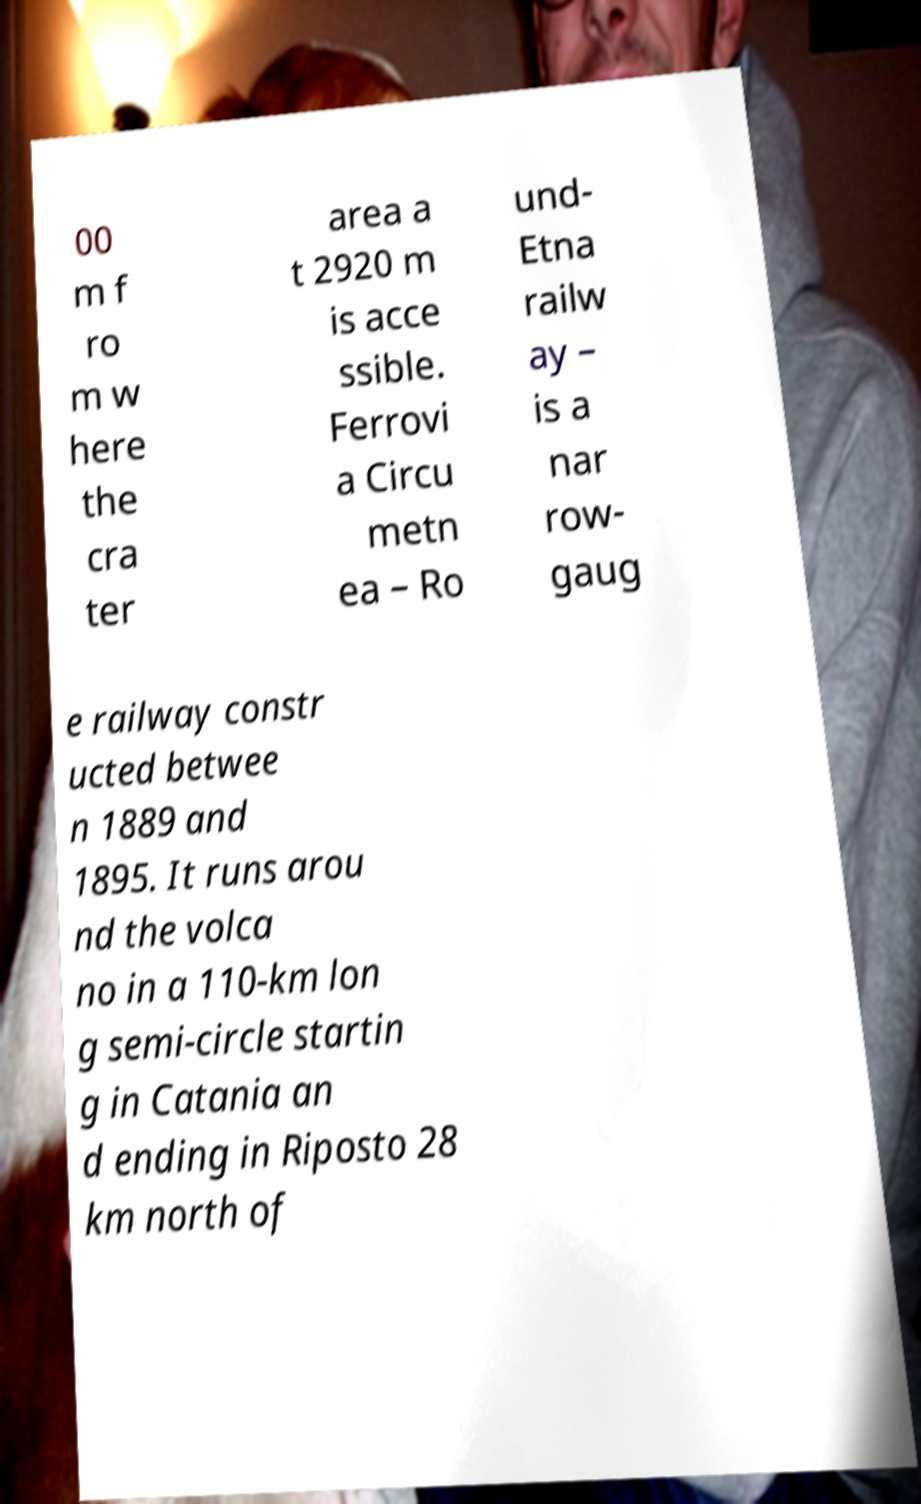Could you assist in decoding the text presented in this image and type it out clearly? 00 m f ro m w here the cra ter area a t 2920 m is acce ssible. Ferrovi a Circu metn ea – Ro und- Etna railw ay – is a nar row- gaug e railway constr ucted betwee n 1889 and 1895. It runs arou nd the volca no in a 110-km lon g semi-circle startin g in Catania an d ending in Riposto 28 km north of 